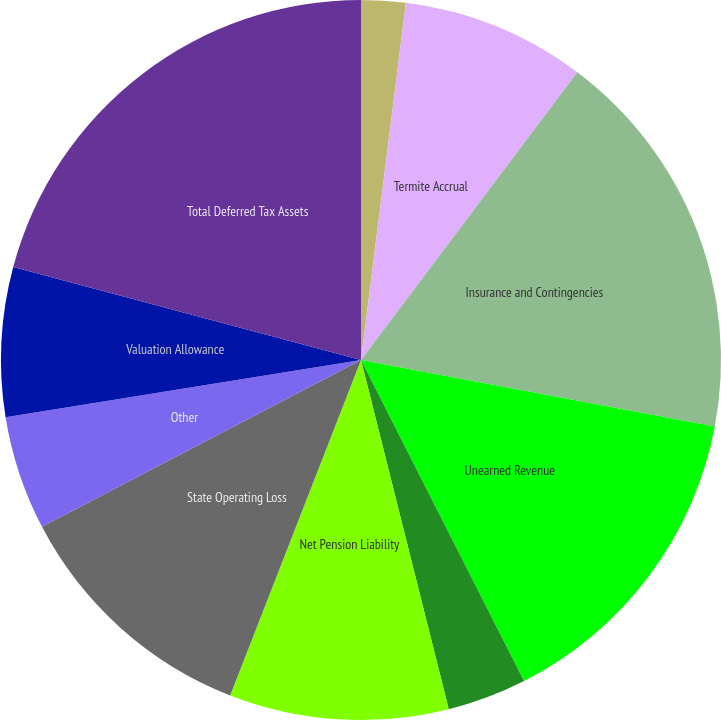<chart> <loc_0><loc_0><loc_500><loc_500><pie_chart><fcel>(in thousands)<fcel>Termite Accrual<fcel>Insurance and Contingencies<fcel>Unearned Revenue<fcel>Compensation Benefits<fcel>Net Pension Liability<fcel>State Operating Loss<fcel>Other<fcel>Valuation Allowance<fcel>Total Deferred Tax Assets<nl><fcel>1.99%<fcel>8.27%<fcel>17.7%<fcel>14.56%<fcel>3.56%<fcel>9.84%<fcel>11.41%<fcel>5.13%<fcel>6.7%<fcel>20.84%<nl></chart> 